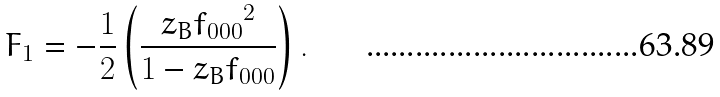Convert formula to latex. <formula><loc_0><loc_0><loc_500><loc_500>F _ { 1 } = - \frac { 1 } { 2 } \left ( \frac { z _ { B } { f _ { 0 0 0 } } ^ { 2 } } { 1 - z _ { B } f _ { 0 0 0 } } \right ) .</formula> 